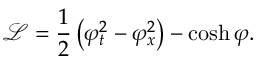Convert formula to latex. <formula><loc_0><loc_0><loc_500><loc_500>{ \mathcal { L } } = { \frac { 1 } { 2 } } \left ( \varphi _ { t } ^ { 2 } - \varphi _ { x } ^ { 2 } \right ) - \cosh \varphi .</formula> 